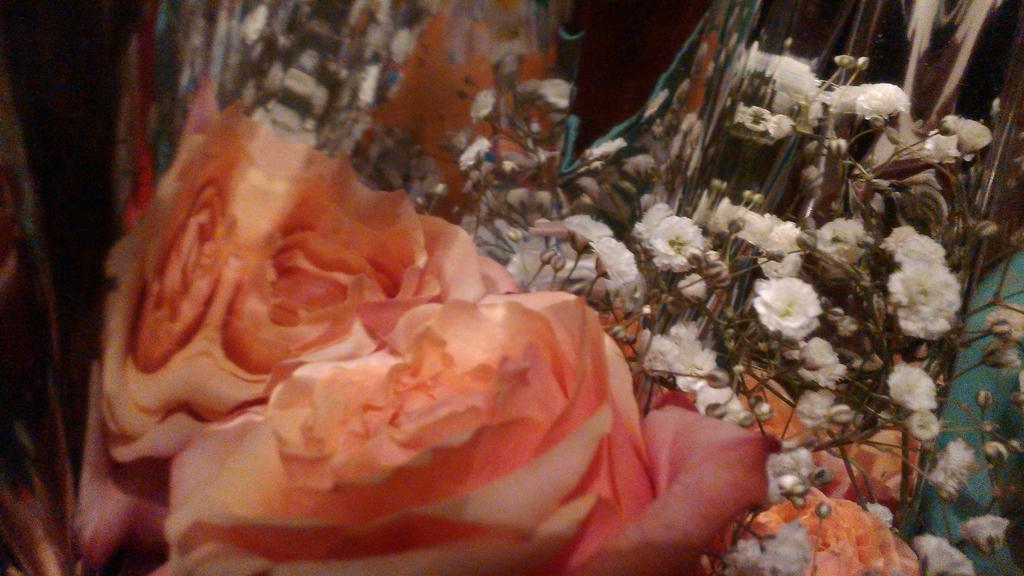Can you describe this image briefly? This image consists of flowering plants kept on the floor. This image is taken may be in a hall. 